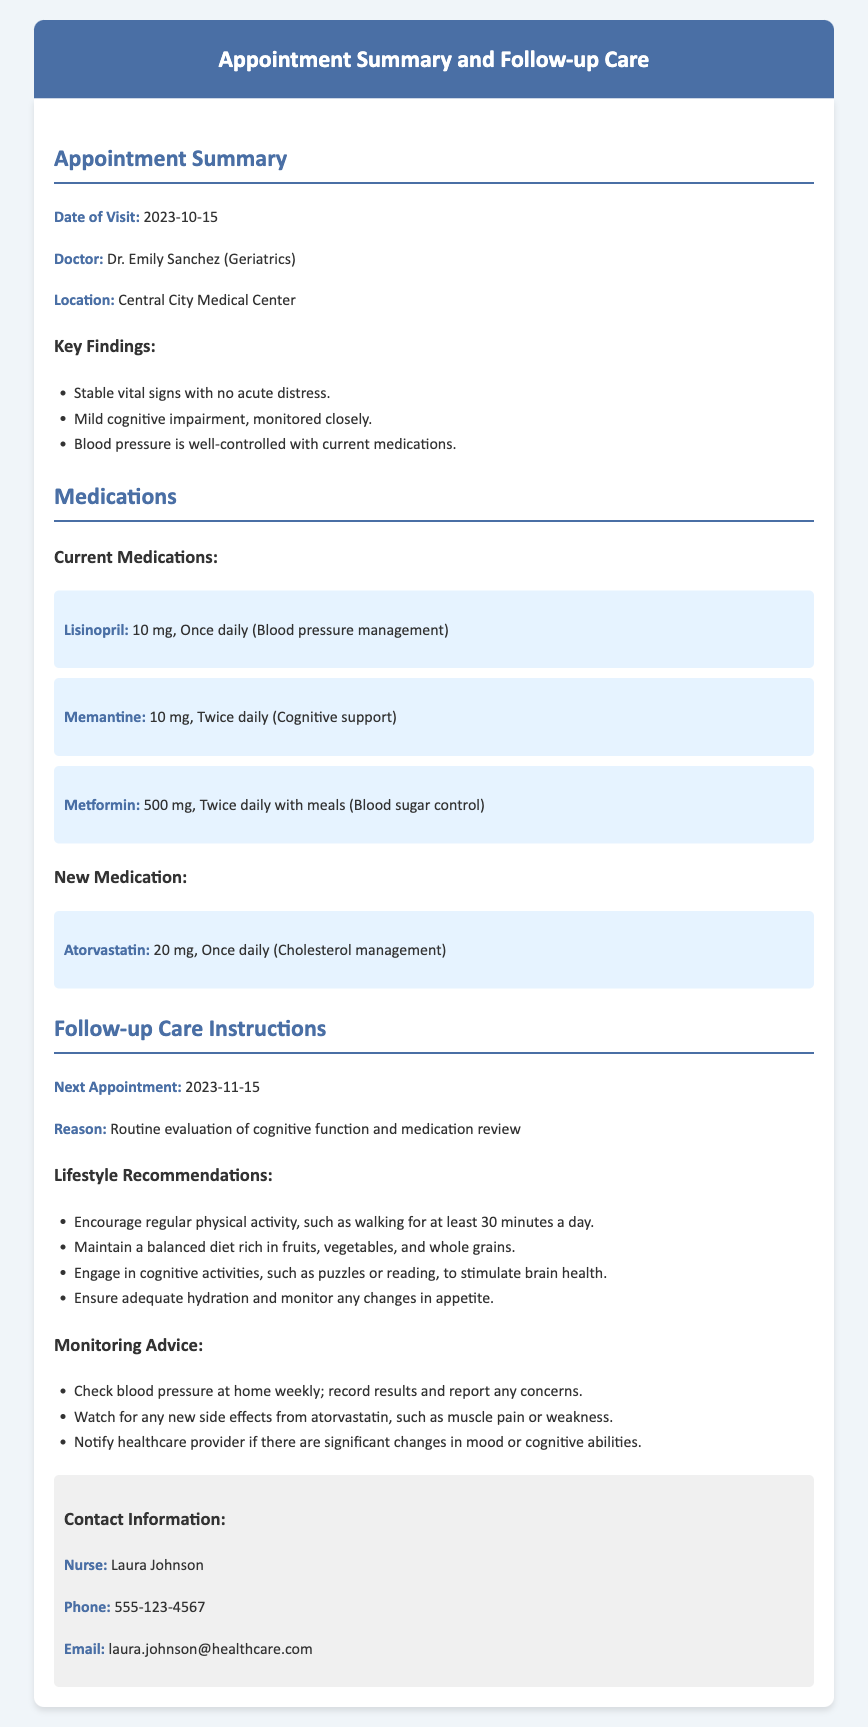what is the date of the visit? The date of the visit is specified in the Appointment Summary section of the document.
Answer: 2023-10-15 who is the doctor? The doctor's name is listed in the Appointment Summary section following the "Doctor:" label.
Answer: Dr. Emily Sanchez what is the new medication prescribed? The new medication is found in the Medications section under "New Medication."
Answer: Atorvastatin when is the next appointment? The next appointment date is mentioned in the Follow-up Care Instructions section.
Answer: 2023-11-15 what is one lifestyle recommendation? There are several lifestyle recommendations provided; this could include any from the list in the document.
Answer: Regular physical activity what should be monitored for side effects? The monitoring advice section outlines what to watch for; this question pertains to the new medication.
Answer: Atorvastatin how much Lisinopril is prescribed? The dosage for Lisinopril is indicated in the Medications section.
Answer: 10 mg why is the next appointment needed? The reason for the next appointment is detailed in the Follow-up Care Instructions section.
Answer: Routine evaluation of cognitive function and medication review what type of medical professional is Dr. Sanchez? The title or specialty of Dr. Sanchez is mentioned in the Appointment Summary section.
Answer: Geriatrics 